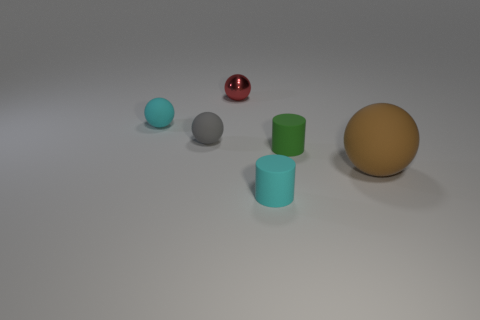Add 3 purple metallic cubes. How many objects exist? 9 Subtract all cylinders. How many objects are left? 4 Add 6 small green objects. How many small green objects are left? 7 Add 3 small shiny objects. How many small shiny objects exist? 4 Subtract 0 brown cylinders. How many objects are left? 6 Subtract all tiny purple matte cylinders. Subtract all tiny cylinders. How many objects are left? 4 